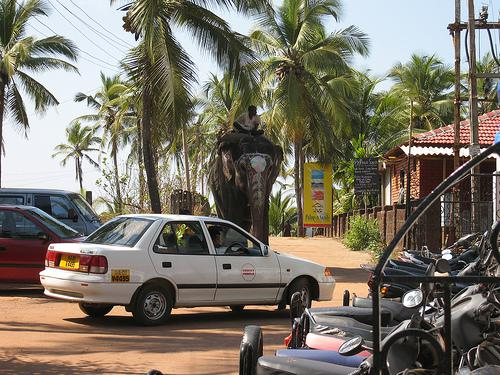Question: what color is the ground?
Choices:
A. Tan.
B. Green.
C. Black.
D. White.
Answer with the letter. Answer: A Question: what color are the palm trees?
Choices:
A. Brown.
B. Green.
C. Yellow.
D. Black.
Answer with the letter. Answer: B Question: what animal is in the photo?
Choices:
A. Rhino.
B. Hippo.
C. Elephant.
D. Giraffe.
Answer with the letter. Answer: C 